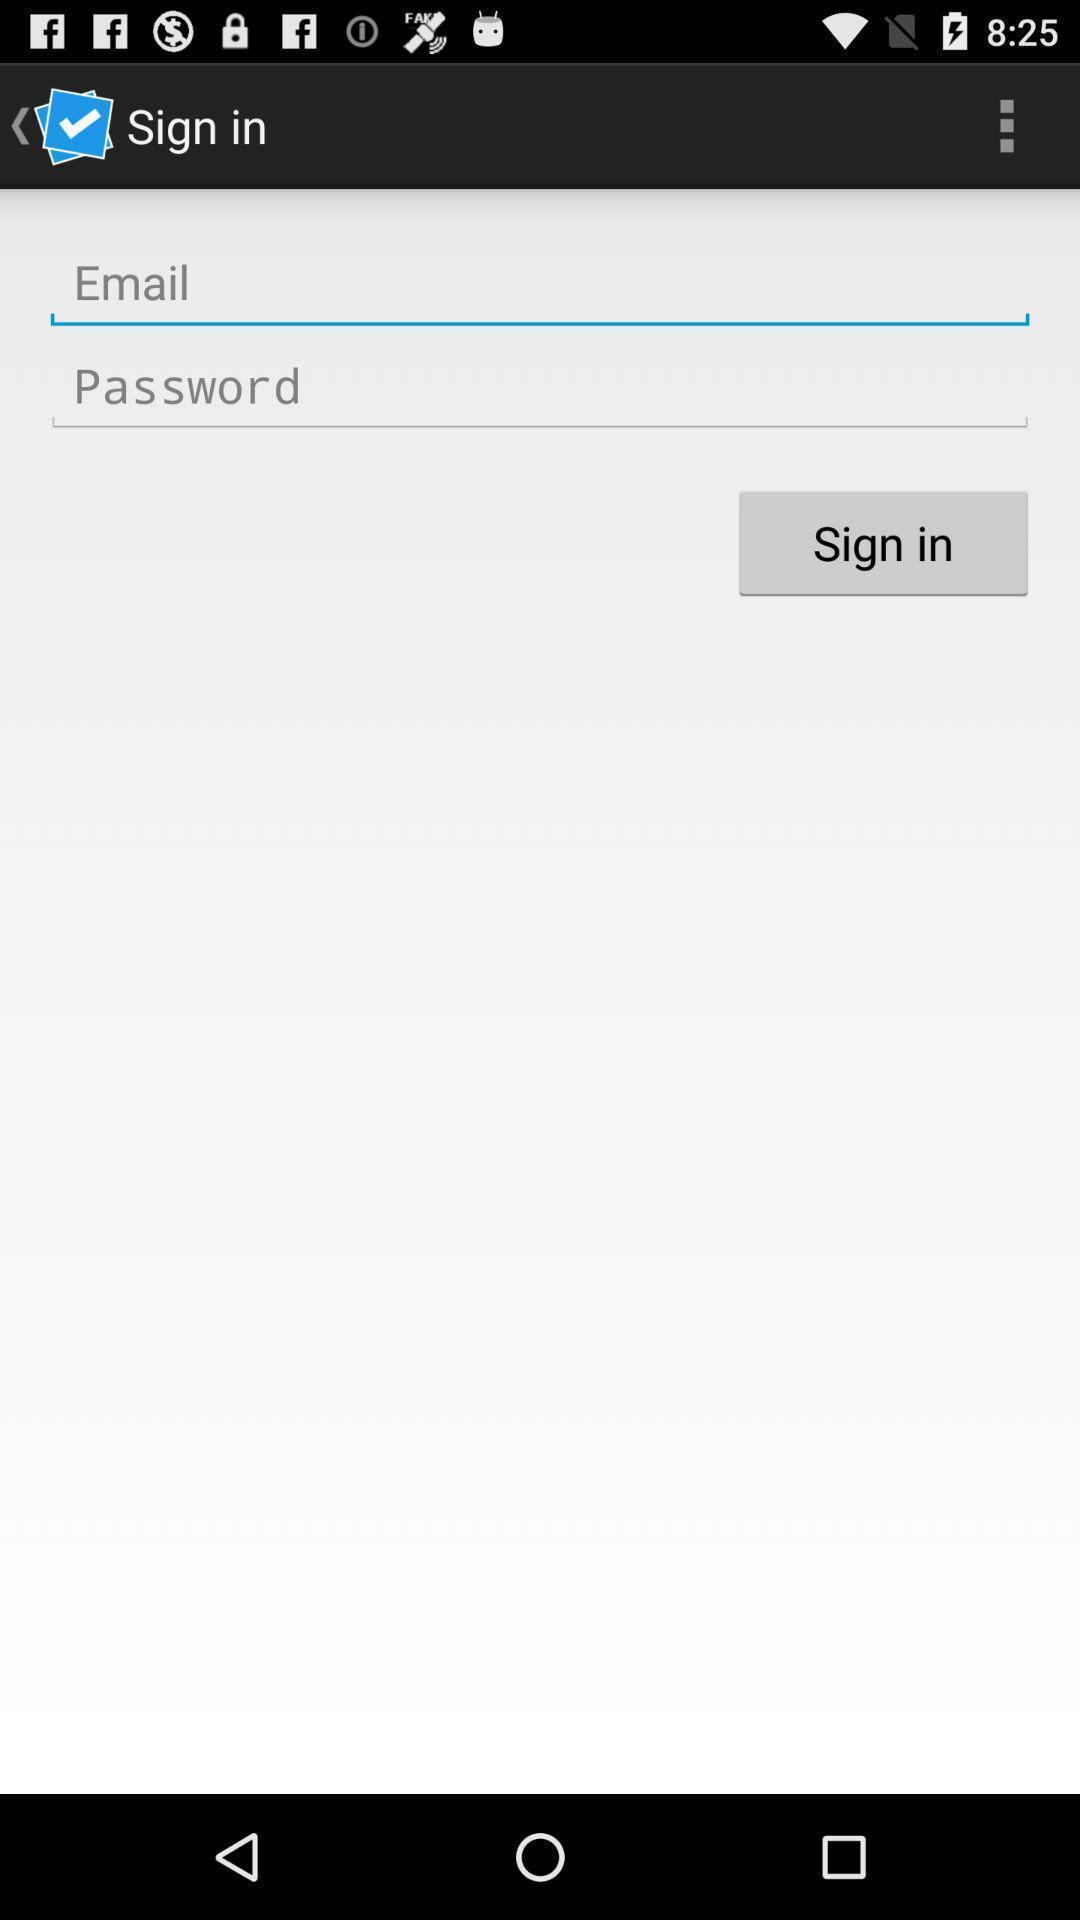Provide a description of this screenshot. Sign up page. 